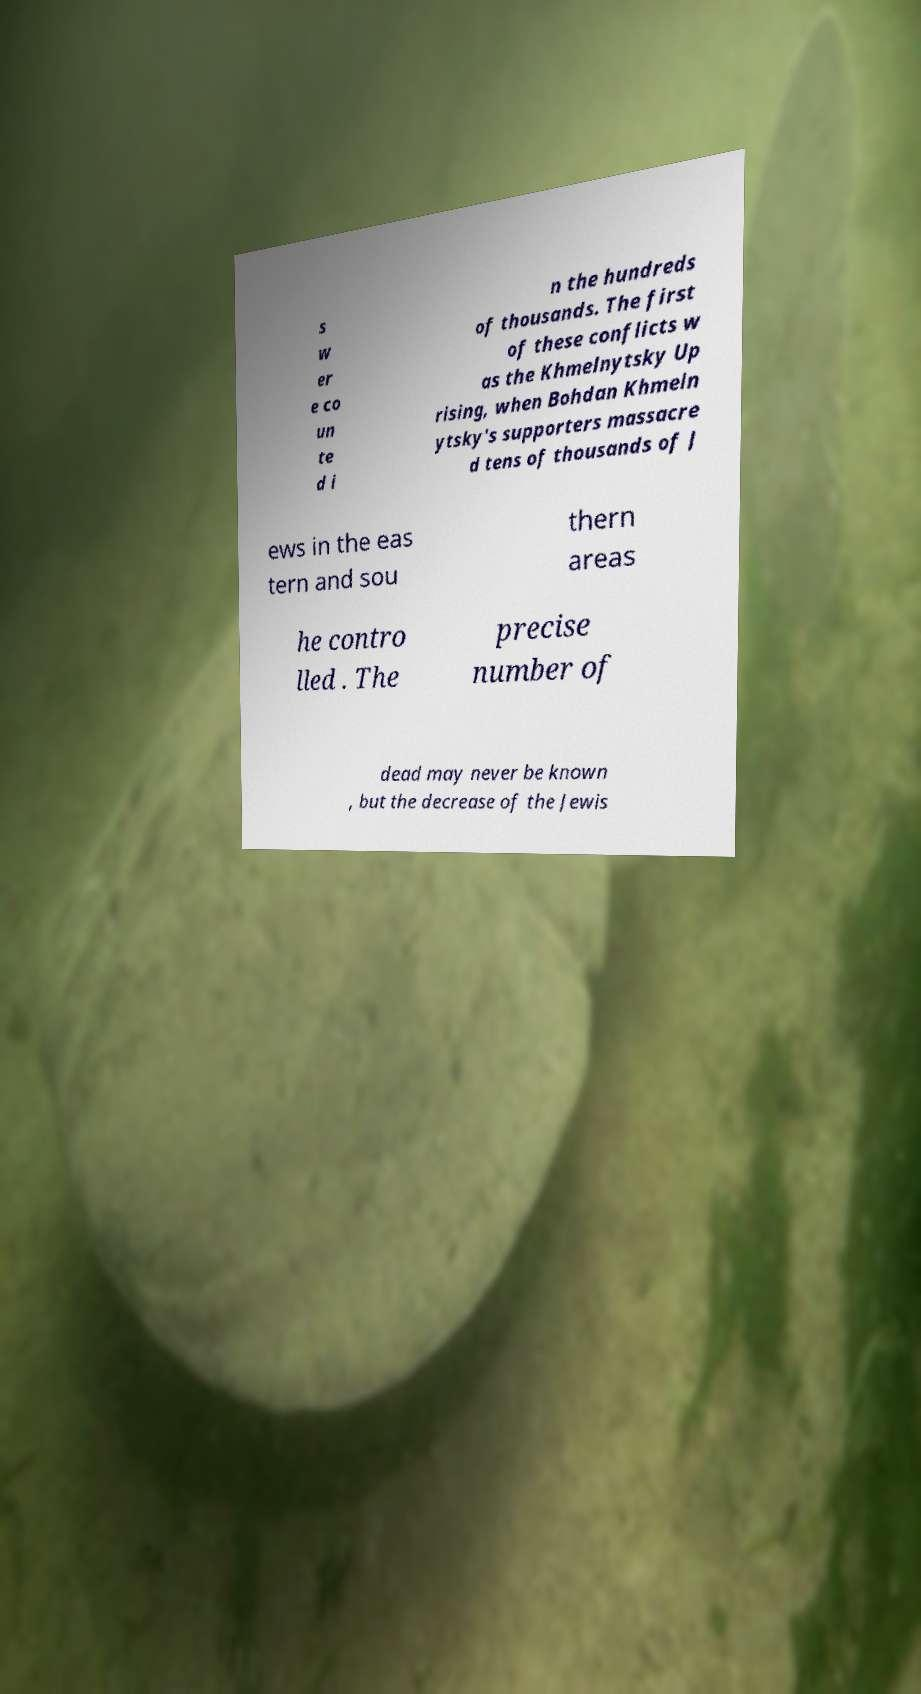Could you extract and type out the text from this image? s w er e co un te d i n the hundreds of thousands. The first of these conflicts w as the Khmelnytsky Up rising, when Bohdan Khmeln ytsky's supporters massacre d tens of thousands of J ews in the eas tern and sou thern areas he contro lled . The precise number of dead may never be known , but the decrease of the Jewis 